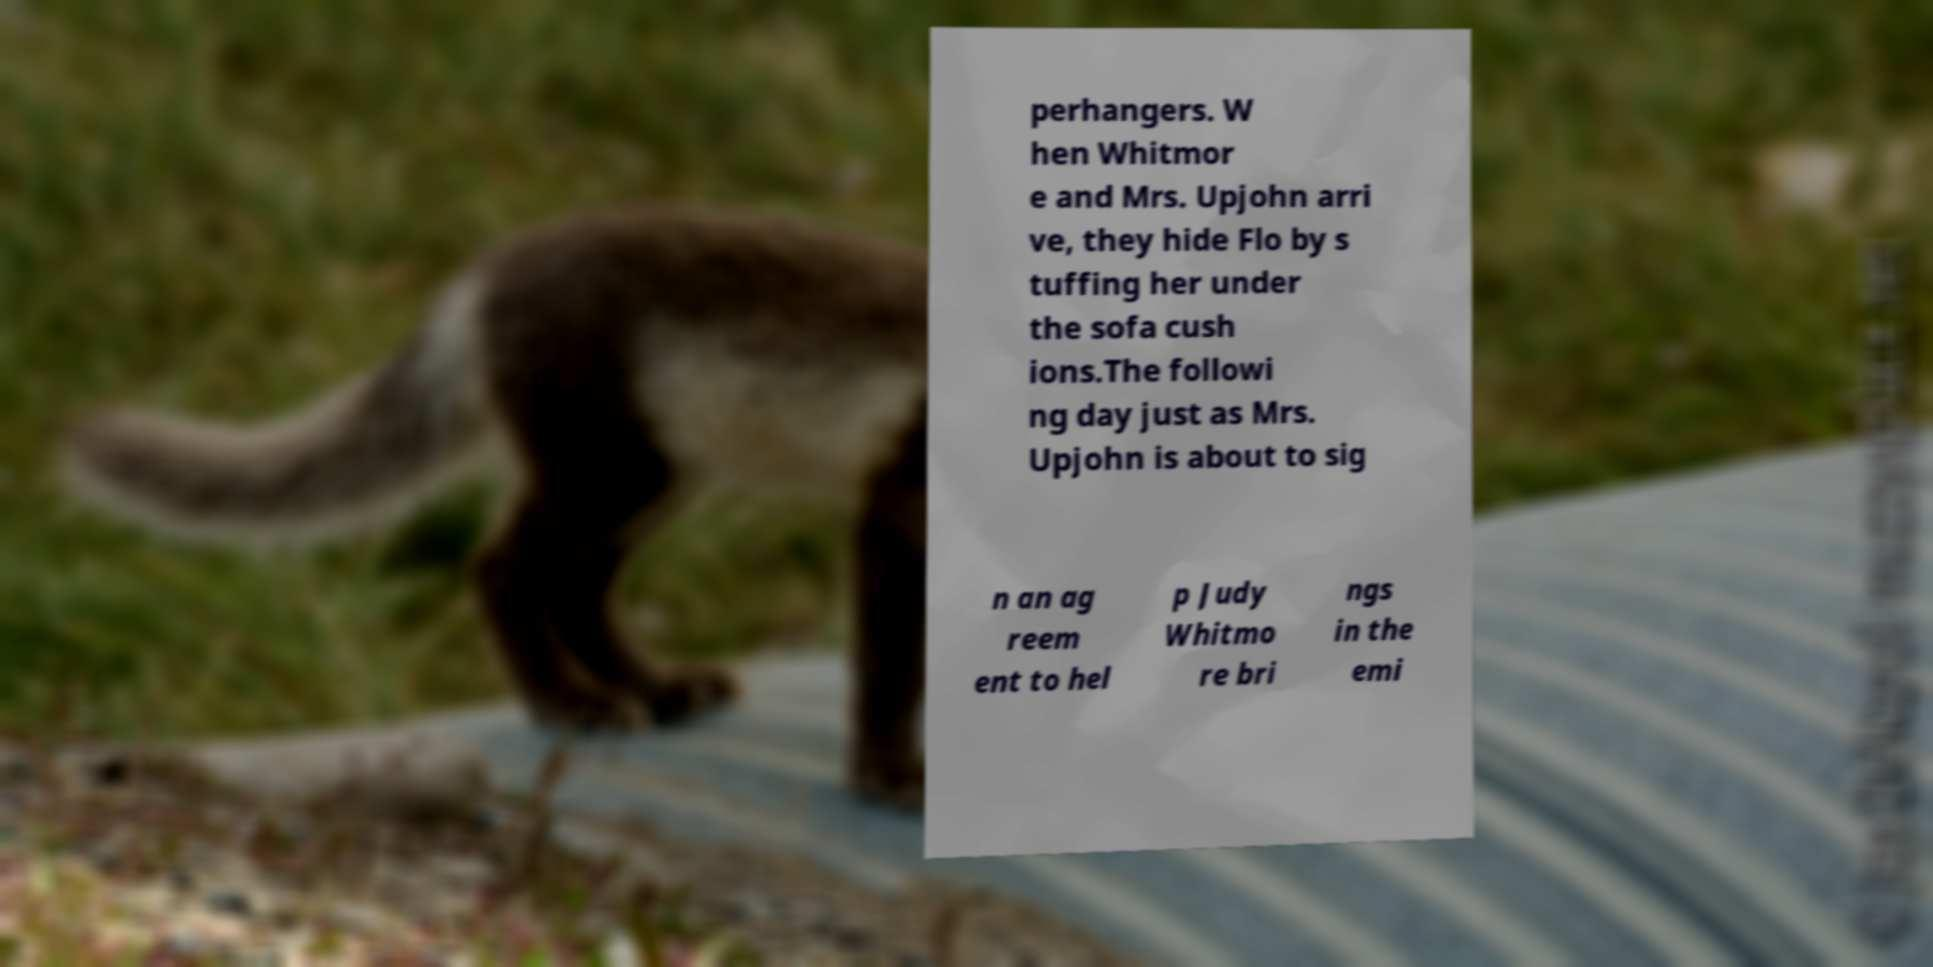Please read and relay the text visible in this image. What does it say? perhangers. W hen Whitmor e and Mrs. Upjohn arri ve, they hide Flo by s tuffing her under the sofa cush ions.The followi ng day just as Mrs. Upjohn is about to sig n an ag reem ent to hel p Judy Whitmo re bri ngs in the emi 